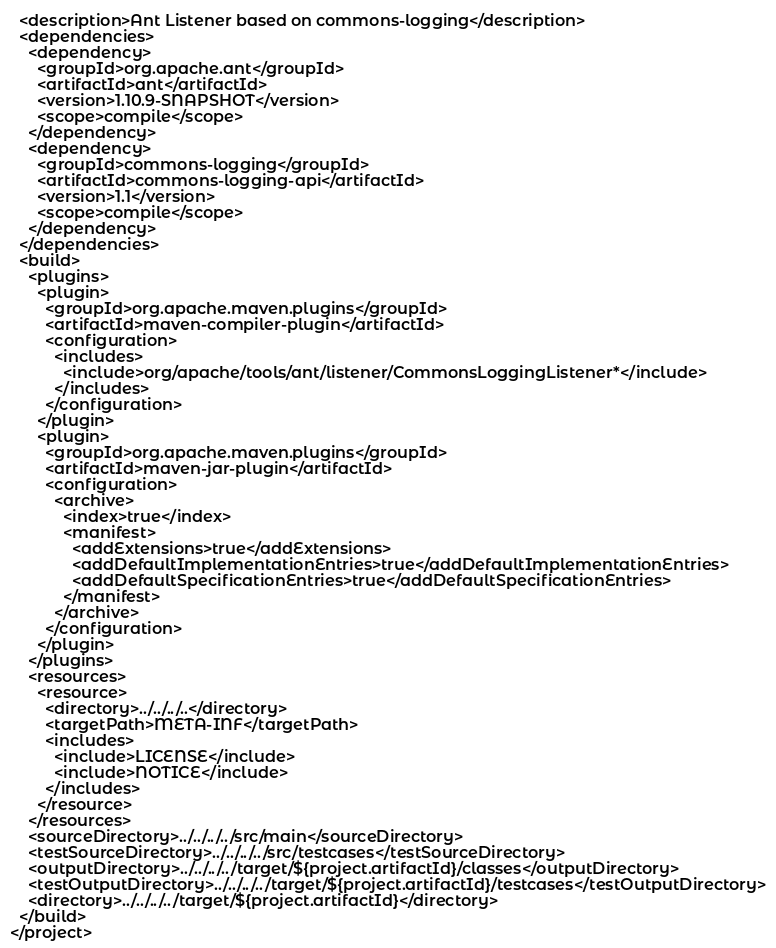<code> <loc_0><loc_0><loc_500><loc_500><_XML_>  <description>Ant Listener based on commons-logging</description>
  <dependencies>
    <dependency>
      <groupId>org.apache.ant</groupId>
      <artifactId>ant</artifactId>
      <version>1.10.9-SNAPSHOT</version>
      <scope>compile</scope>
    </dependency>
    <dependency>
      <groupId>commons-logging</groupId>
      <artifactId>commons-logging-api</artifactId>
      <version>1.1</version>
      <scope>compile</scope>
    </dependency>
  </dependencies>
  <build>
    <plugins>
      <plugin>
        <groupId>org.apache.maven.plugins</groupId>
        <artifactId>maven-compiler-plugin</artifactId>
        <configuration>
          <includes>
            <include>org/apache/tools/ant/listener/CommonsLoggingListener*</include>
          </includes>
        </configuration>
      </plugin>
      <plugin>
        <groupId>org.apache.maven.plugins</groupId>
        <artifactId>maven-jar-plugin</artifactId>
        <configuration>
          <archive>
            <index>true</index>
            <manifest>
              <addExtensions>true</addExtensions>
              <addDefaultImplementationEntries>true</addDefaultImplementationEntries>
              <addDefaultSpecificationEntries>true</addDefaultSpecificationEntries>
            </manifest>
          </archive>
        </configuration>
      </plugin>
    </plugins>
    <resources>
      <resource>
        <directory>../../../..</directory>
        <targetPath>META-INF</targetPath>
        <includes>
          <include>LICENSE</include>
          <include>NOTICE</include>
        </includes>
      </resource>
    </resources>
    <sourceDirectory>../../../../src/main</sourceDirectory>
    <testSourceDirectory>../../../../src/testcases</testSourceDirectory>
    <outputDirectory>../../../../target/${project.artifactId}/classes</outputDirectory>
    <testOutputDirectory>../../../../target/${project.artifactId}/testcases</testOutputDirectory>
    <directory>../../../../target/${project.artifactId}</directory>
  </build>
</project>
</code> 